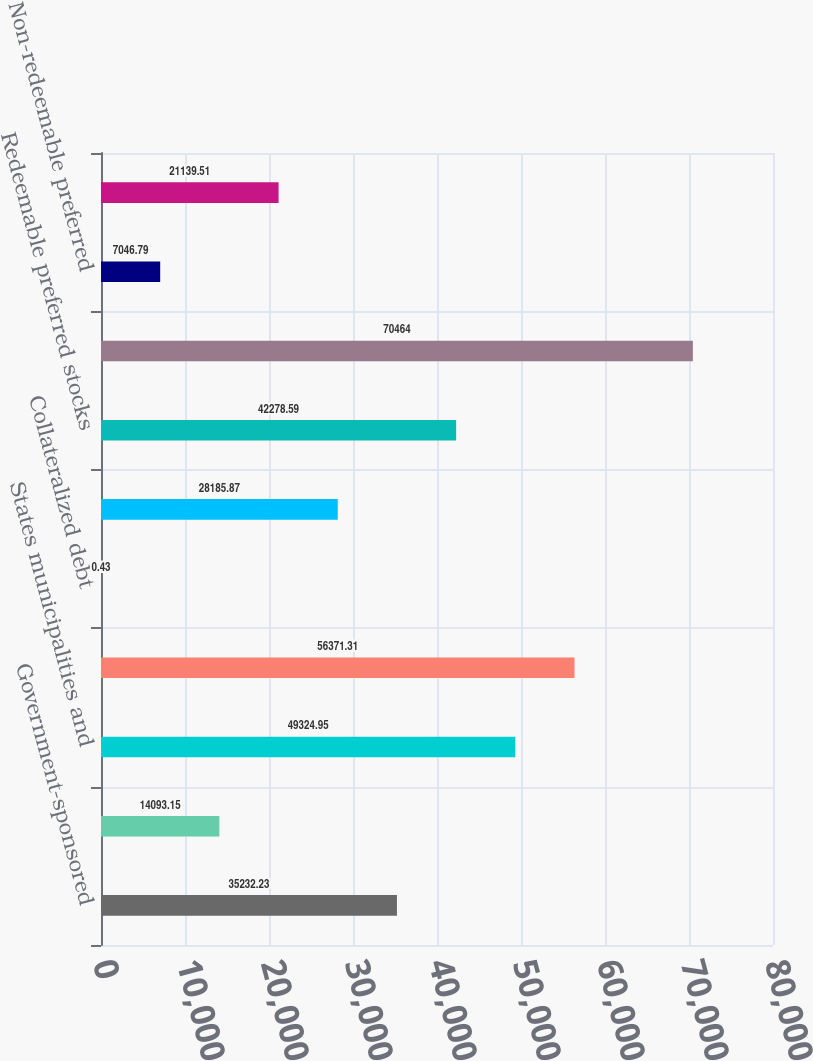Convert chart to OTSL. <chart><loc_0><loc_0><loc_500><loc_500><bar_chart><fcel>Government-sponsored<fcel>GNMAs<fcel>States municipalities and<fcel>Corporates<fcel>Collateralized debt<fcel>Asset-backed securities<fcel>Redeemable preferred stocks<fcel>Total fixed maturities<fcel>Non-redeemable preferred<fcel>Total equity securities<nl><fcel>35232.2<fcel>14093.1<fcel>49324.9<fcel>56371.3<fcel>0.43<fcel>28185.9<fcel>42278.6<fcel>70464<fcel>7046.79<fcel>21139.5<nl></chart> 